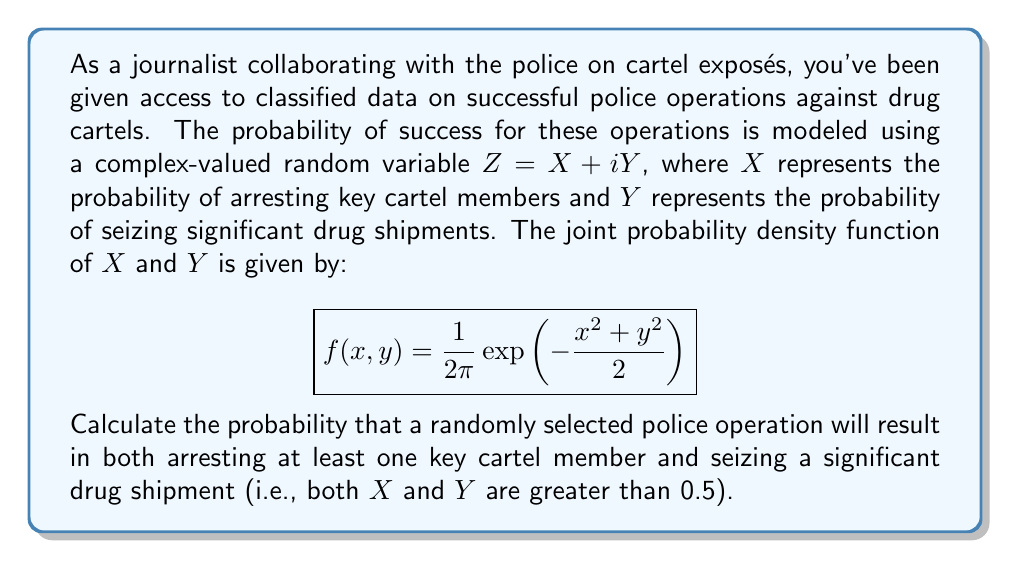Help me with this question. To solve this problem, we need to integrate the joint probability density function over the region where both $X$ and $Y$ are greater than 0.5. Here's the step-by-step solution:

1) The region of integration is a quarter of the first quadrant, where $x > 0.5$ and $y > 0.5$.

2) We need to calculate the double integral:

   $$P(X > 0.5, Y > 0.5) = \int_{0.5}^{\infty}\int_{0.5}^{\infty} f(x,y) \, dy \, dx$$

3) Substituting the given probability density function:

   $$P(X > 0.5, Y > 0.5) = \int_{0.5}^{\infty}\int_{0.5}^{\infty} \frac{1}{2\pi}\exp\left(-\frac{x^2+y^2}{2}\right) \, dy \, dx$$

4) This integral doesn't have a simple closed-form solution, so we need to use numerical methods to evaluate it. One approach is to use the error function (erf):

   $$P(X > 0.5, Y > 0.5) = \frac{1}{4}\left[1 - \text{erf}\left(\frac{0.5}{\sqrt{2}}\right)\right]^2$$

5) Using a calculator or computer algebra system to evaluate this expression:

   $$P(X > 0.5, Y > 0.5) \approx 0.0874$$

Therefore, the probability that a randomly selected police operation will result in both arresting at least one key cartel member and seizing a significant drug shipment is approximately 0.0874 or 8.74%.
Answer: The probability is approximately 0.0874 or 8.74%. 